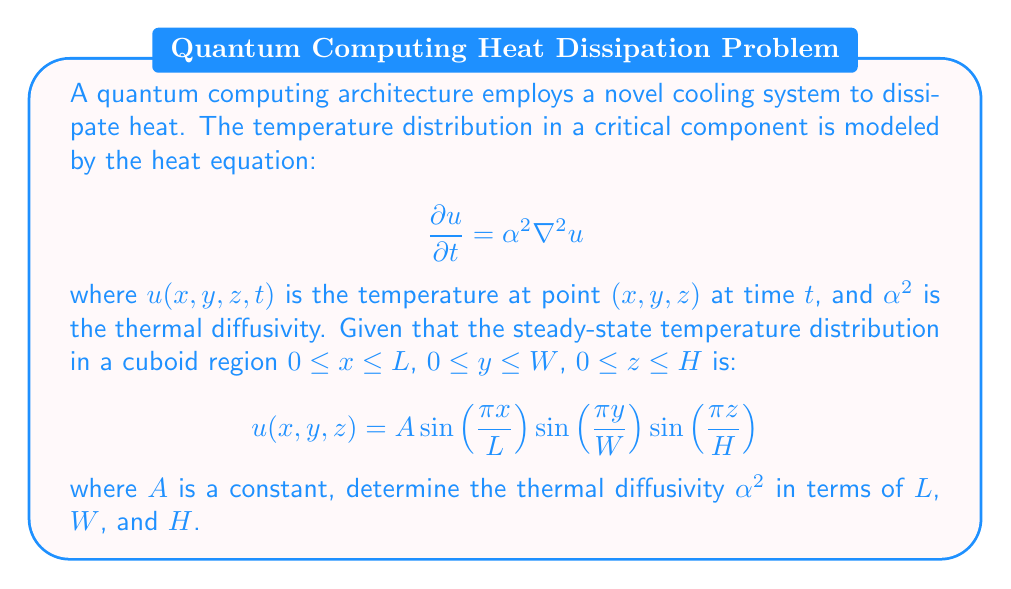Give your solution to this math problem. To solve this problem, we'll follow these steps:

1) The steady-state solution must satisfy the time-independent heat equation:

   $$\nabla^2 u = 0$$

2) We need to calculate $\nabla^2 u$ for the given temperature distribution:

   $$u(x,y,z) = A \sin(\frac{\pi x}{L}) \sin(\frac{\pi y}{W}) \sin(\frac{\pi z}{H})$$

3) Calculate the second partial derivatives:

   $$\frac{\partial^2 u}{\partial x^2} = -A (\frac{\pi}{L})^2 \sin(\frac{\pi x}{L}) \sin(\frac{\pi y}{W}) \sin(\frac{\pi z}{H})$$
   
   $$\frac{\partial^2 u}{\partial y^2} = -A (\frac{\pi}{W})^2 \sin(\frac{\pi x}{L}) \sin(\frac{\pi y}{W}) \sin(\frac{\pi z}{H})$$
   
   $$\frac{\partial^2 u}{\partial z^2} = -A (\frac{\pi}{H})^2 \sin(\frac{\pi x}{L}) \sin(\frac{\pi y}{W}) \sin(\frac{\pi z}{H})$$

4) Sum these to get $\nabla^2 u$:

   $$\nabla^2 u = -A [(\frac{\pi}{L})^2 + (\frac{\pi}{W})^2 + (\frac{\pi}{H})^2] \sin(\frac{\pi x}{L}) \sin(\frac{\pi y}{W}) \sin(\frac{\pi z}{H})$$

5) For this to satisfy $\nabla^2 u = 0$, we must have:

   $$(\frac{\pi}{L})^2 + (\frac{\pi}{W})^2 + (\frac{\pi}{H})^2 = 0$$

6) However, this is impossible for real, non-zero $L$, $W$, and $H$. Therefore, the given solution must satisfy the time-dependent heat equation:

   $$\frac{\partial u}{\partial t} = \alpha^2 \nabla^2 u$$

7) The left-hand side is zero (steady-state), so:

   $$0 = -\alpha^2 A [(\frac{\pi}{L})^2 + (\frac{\pi}{W})^2 + (\frac{\pi}{H})^2] \sin(\frac{\pi x}{L}) \sin(\frac{\pi y}{W}) \sin(\frac{\pi z}{H})$$

8) For this to be true for all $x$, $y$, and $z$, we must have:

   $$\alpha^2 [(\frac{\pi}{L})^2 + (\frac{\pi}{W})^2 + (\frac{\pi}{H})^2] = 0$$

9) Solving for $\alpha^2$:

   $$\alpha^2 = \frac{1}{(\frac{1}{L^2} + \frac{1}{W^2} + \frac{1}{H^2})}$$
Answer: $$\alpha^2 = \frac{1}{(\frac{1}{L^2} + \frac{1}{W^2} + \frac{1}{H^2})}$$ 